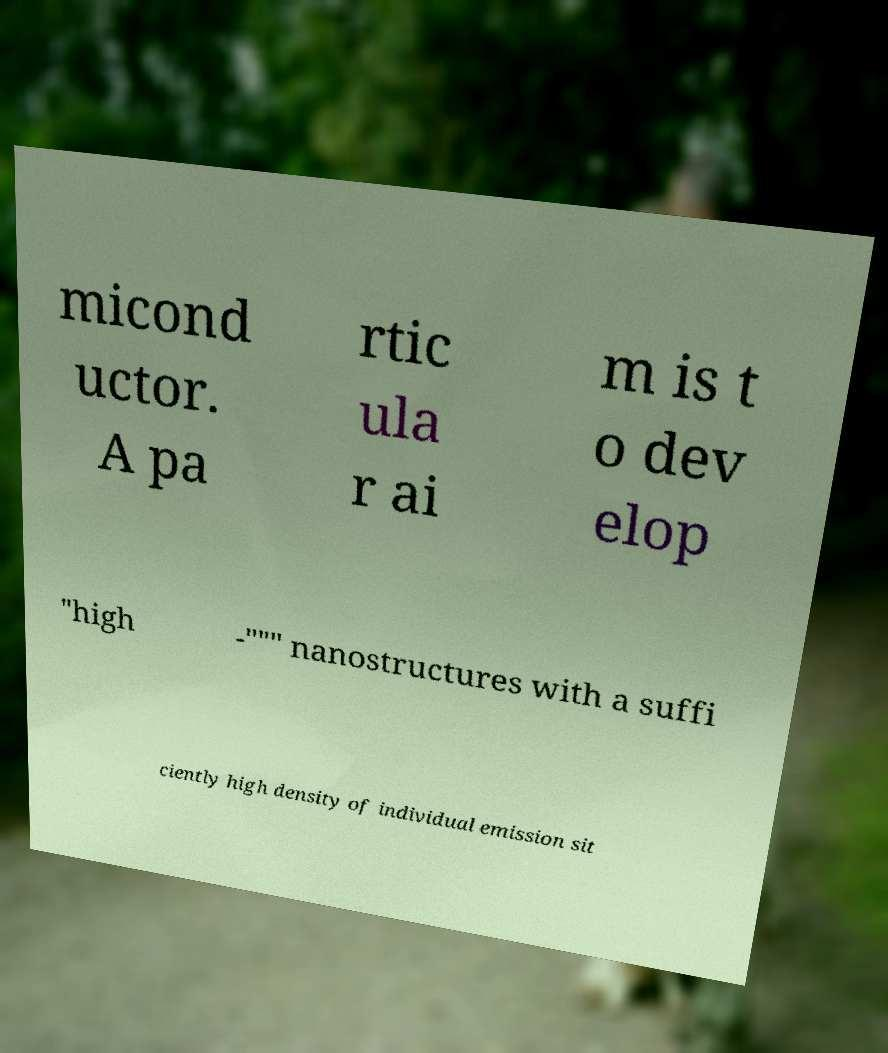What messages or text are displayed in this image? I need them in a readable, typed format. micond uctor. A pa rtic ula r ai m is t o dev elop "high -""" nanostructures with a suffi ciently high density of individual emission sit 